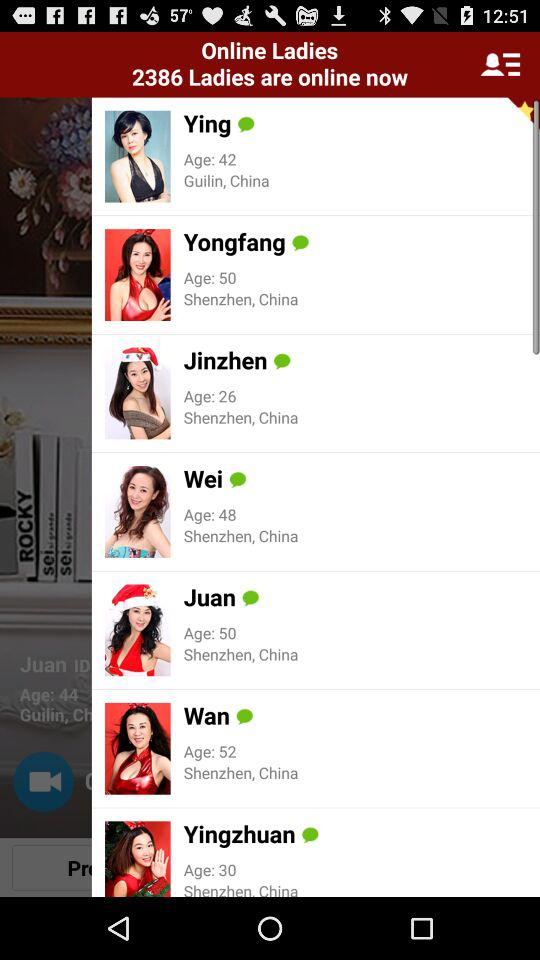How many ladies are online? There are 2386 ladies online. 